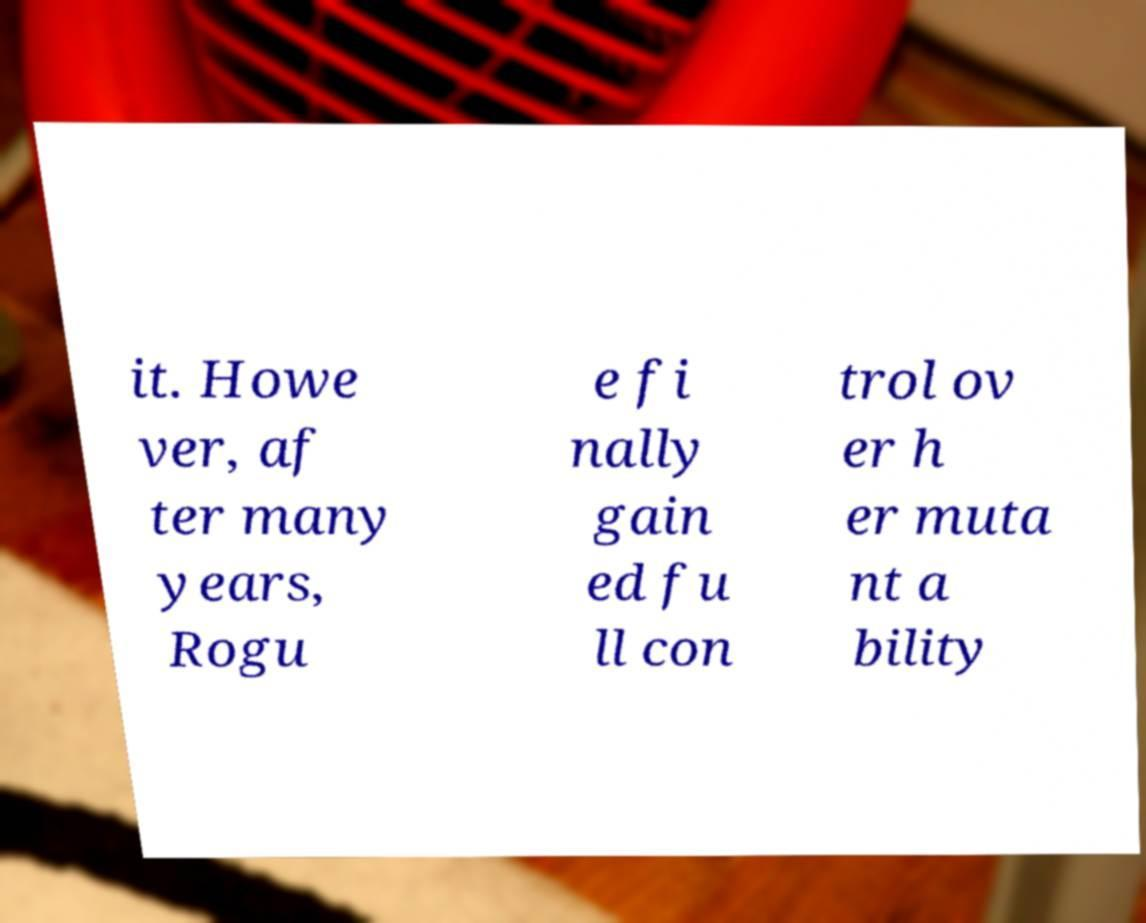I need the written content from this picture converted into text. Can you do that? it. Howe ver, af ter many years, Rogu e fi nally gain ed fu ll con trol ov er h er muta nt a bility 